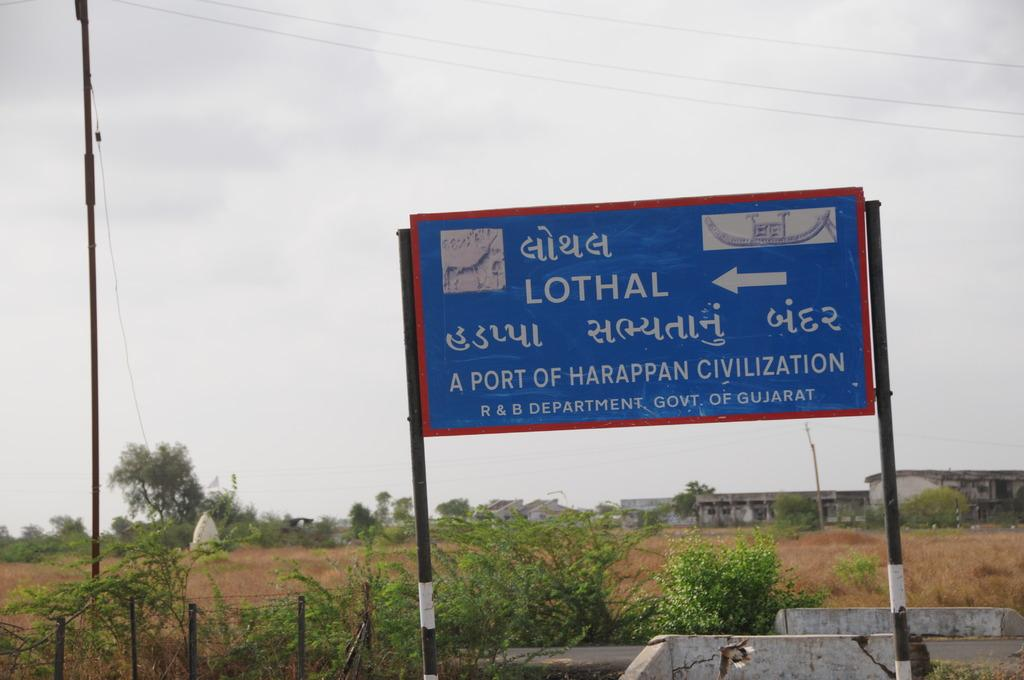<image>
Render a clear and concise summary of the photo. Blue and red sign that says "Lothal" and has an arrow. 